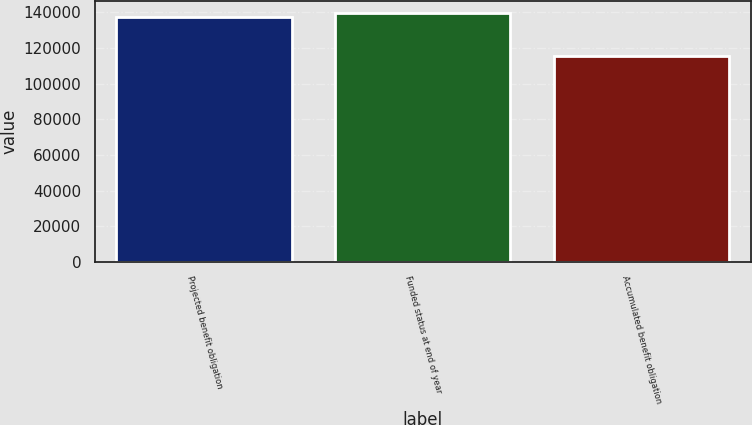Convert chart. <chart><loc_0><loc_0><loc_500><loc_500><bar_chart><fcel>Projected benefit obligation<fcel>Funded status at end of year<fcel>Accumulated benefit obligation<nl><fcel>137271<fcel>139470<fcel>115286<nl></chart> 